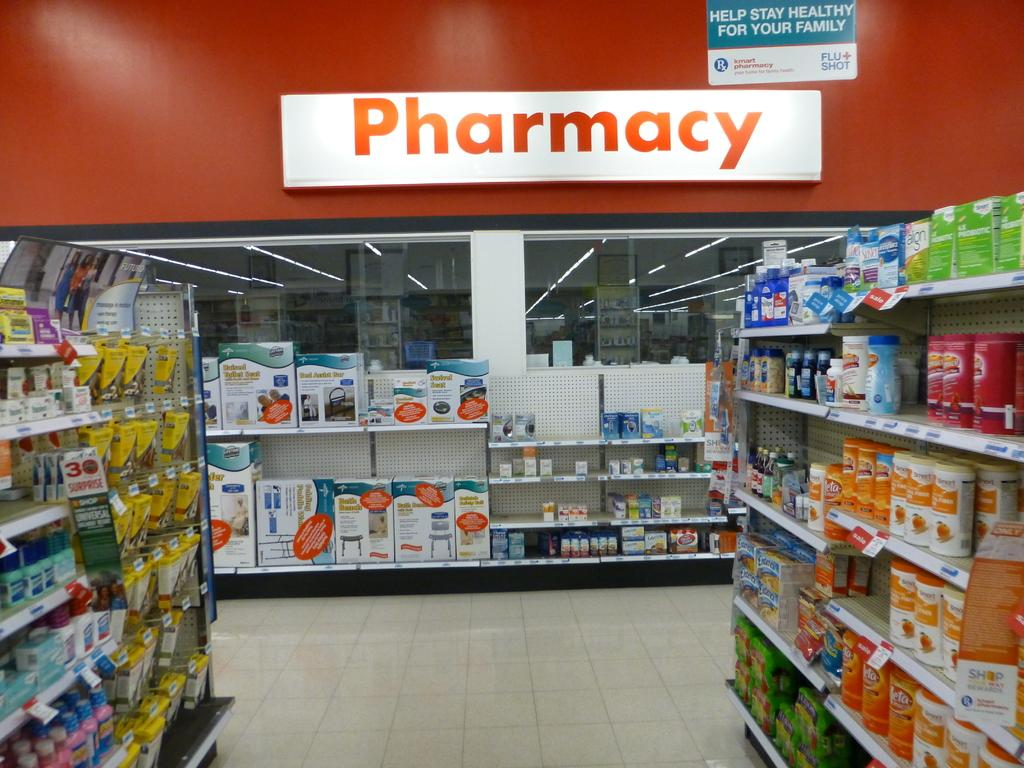<image>
Share a concise interpretation of the image provided. A store that shows the pharmacy section with various products along the aisles 